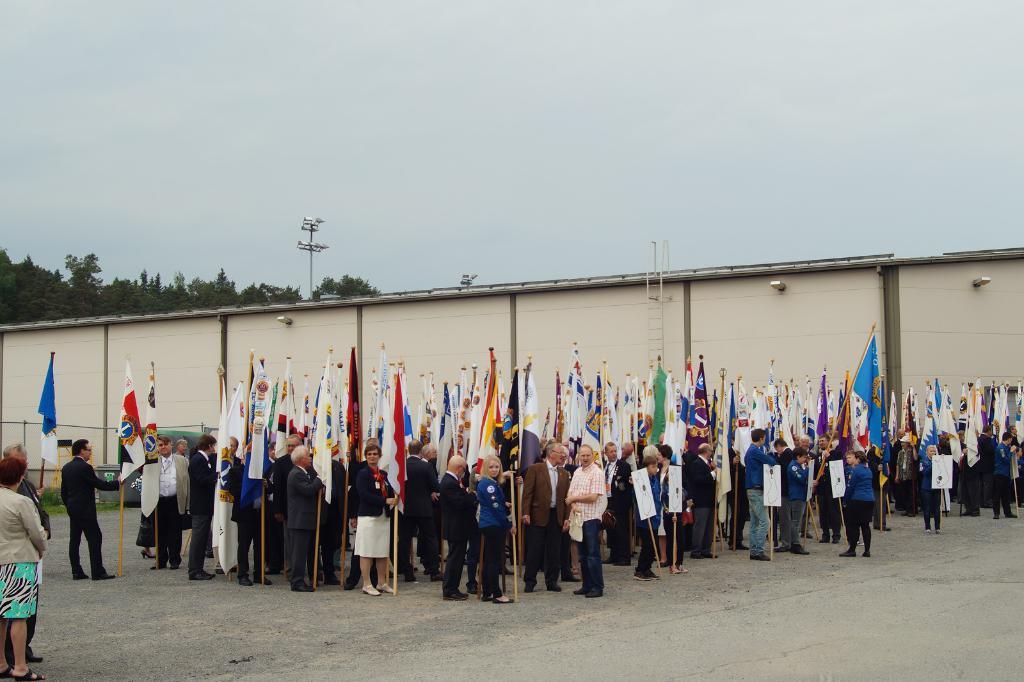Can you describe this image briefly? At the bottom of the image few people are standing and holding sticks and flags. Behind them there is a building. Behind the building there are some trees and poles. At the top of the image there is sky. 